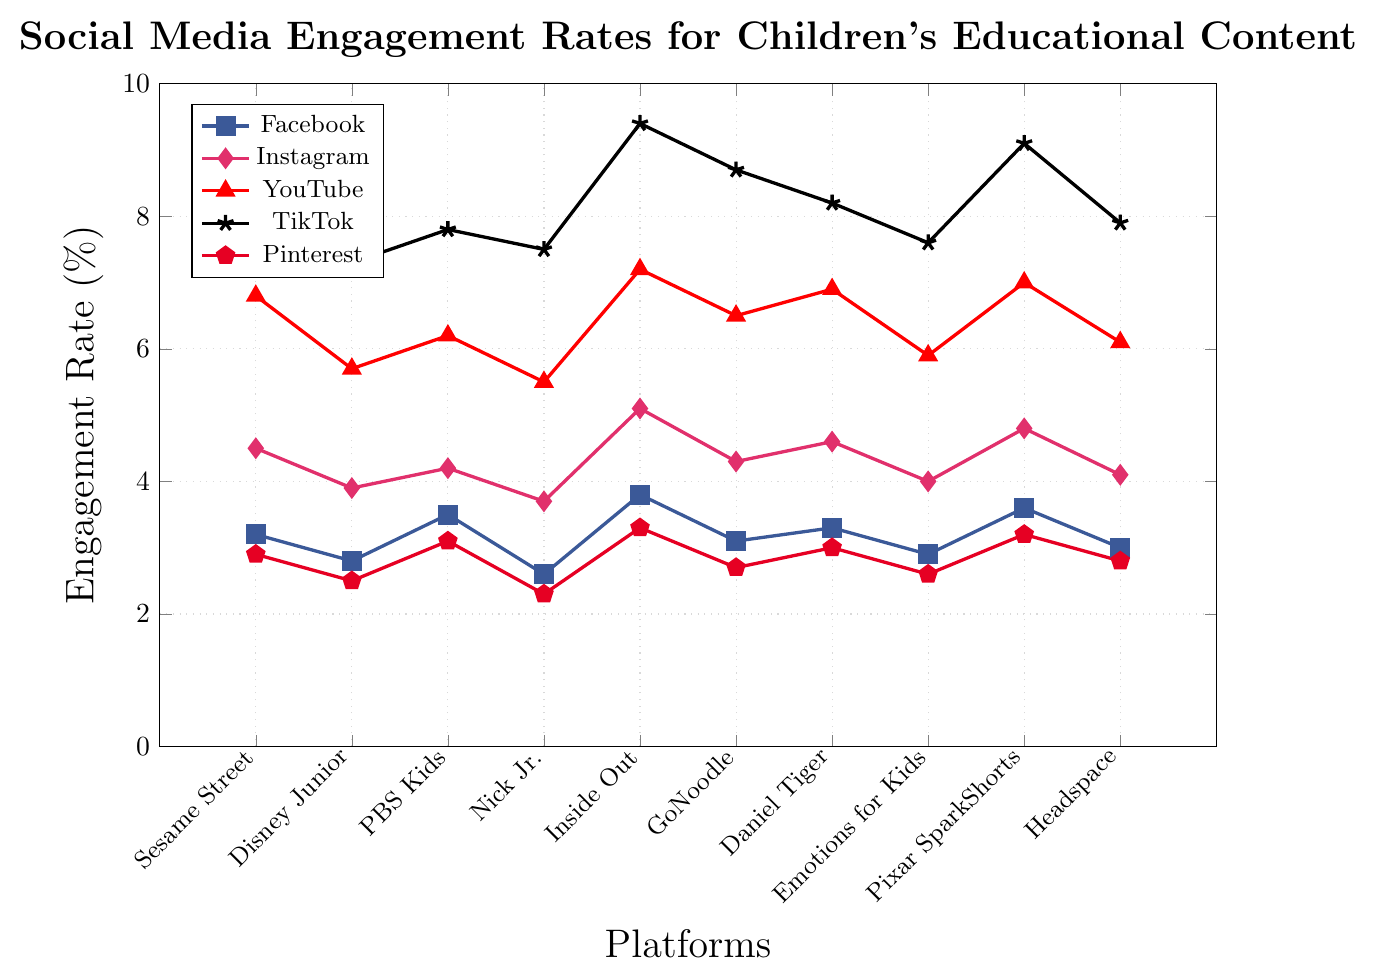Which platform has the highest engagement rate for children's educational content on TikTok? To find the platform with the highest engagement rate on TikTok, look for the highest value among the TikTok data points on the chart. Inside Out Official has the highest value at 9.4%.
Answer: Inside Out Official What is the average engagement rate for PBS Kids across all platforms? Add the engagement rates for PBS Kids across all platforms: (3.5 + 4.2 + 6.2 + 7.8 + 3.1). Then, divide by the number of platforms (5). The calculation is (3.5 + 4.2 + 6.2 + 7.8 + 3.1) / 5 = 24.8 / 5 = 4.96%.
Answer: 4.96% Which platform shows the least engagement on Pinterest? Identify the lowest point in the Pinterest data series. The lowest value is 2.3% for Nick Jr.
Answer: Nick Jr How much higher is the engagement rate for Inside Out Official on YouTube compared to Facebook? Find the engagement rates for Inside Out Official on YouTube and Facebook. Then, subtract the Facebook rate from the YouTube rate: 7.2% - 3.8% = 3.4%.
Answer: 3.4% Which platforms have an engagement rate greater than 7% on YouTube? Look at the YouTube data points and identify those greater than 7%. The platforms are Inside Out Official (7.2%), Pixar SparkShorts (7.0%), and Daniel Tiger's Neighborhood (6.9%). Only Inside Out Official and Pixar SparkShorts exceed 7%.
Answer: Inside Out Official, Pixar SparkShorts What is the engagement rate difference between TikTok and Instagram for Sesame Street? Look at the engagement rates for Sesame Street on TikTok and Instagram. Subtract the Instagram rate from the TikTok rate: 8.1% - 4.5% = 3.6%.
Answer: 3.6% Rank the platforms in descending order of engagement rate on Facebook. Observe the Facebook data points and sort them from highest to lowest: Inside Out Official (3.8%), Pixar SparkShorts (3.6%), PBS Kids (3.5%), Daniel Tiger's Neighborhood (3.3%), Sesame Street (3.2%), GoNoodle (3.1%), Headspace for Kids (3.0%), Emotions for Kids (2.9%), Disney Junior (2.8%), Nick Jr. (2.6%).
Answer: Inside Out Official, Pixar SparkShorts, PBS Kids, Daniel Tiger's Neighborhood, Sesame Street, GoNoodle, Headspace for Kids, Emotions for Kids, Disney Junior, Nick Jr Which platform has the most consistently high engagement rates across all social media platforms? Examine the engagement rates for each platform across all social media platforms and look for the one with consistently high values. Inside Out Official has consistently high engagement rates on all platforms.
Answer: Inside Out Official 